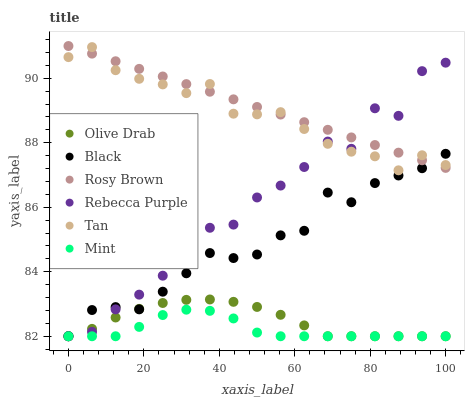Does Mint have the minimum area under the curve?
Answer yes or no. Yes. Does Rosy Brown have the maximum area under the curve?
Answer yes or no. Yes. Does Black have the minimum area under the curve?
Answer yes or no. No. Does Black have the maximum area under the curve?
Answer yes or no. No. Is Rosy Brown the smoothest?
Answer yes or no. Yes. Is Rebecca Purple the roughest?
Answer yes or no. Yes. Is Black the smoothest?
Answer yes or no. No. Is Black the roughest?
Answer yes or no. No. Does Black have the lowest value?
Answer yes or no. Yes. Does Tan have the lowest value?
Answer yes or no. No. Does Rosy Brown have the highest value?
Answer yes or no. Yes. Does Black have the highest value?
Answer yes or no. No. Is Mint less than Tan?
Answer yes or no. Yes. Is Tan greater than Mint?
Answer yes or no. Yes. Does Rebecca Purple intersect Mint?
Answer yes or no. Yes. Is Rebecca Purple less than Mint?
Answer yes or no. No. Is Rebecca Purple greater than Mint?
Answer yes or no. No. Does Mint intersect Tan?
Answer yes or no. No. 